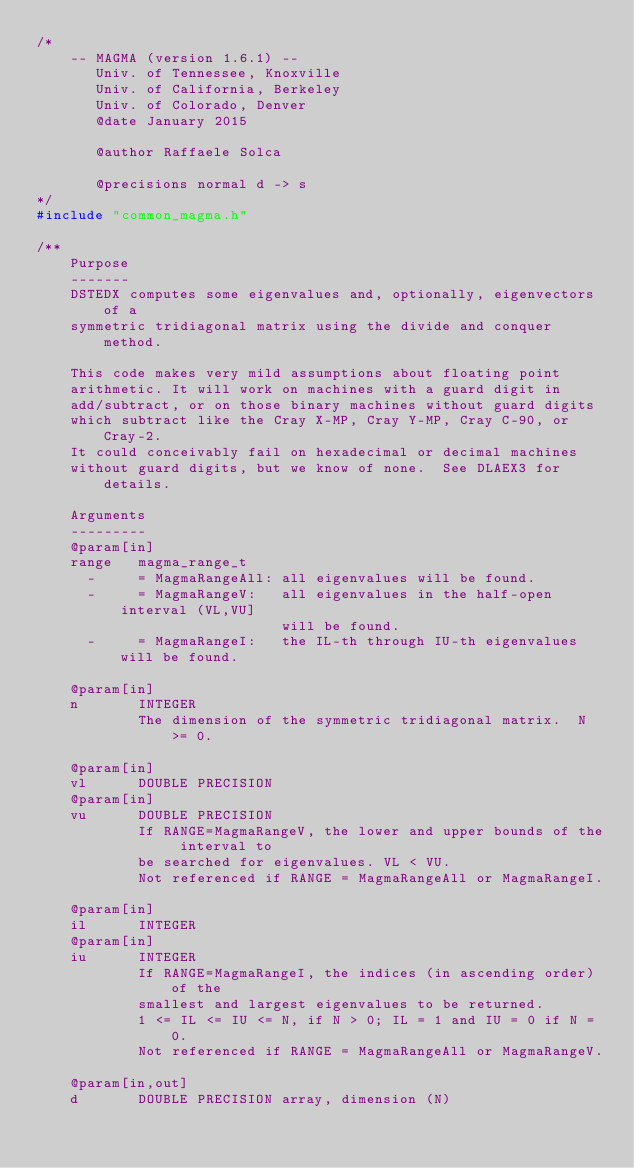<code> <loc_0><loc_0><loc_500><loc_500><_C++_>/*
    -- MAGMA (version 1.6.1) --
       Univ. of Tennessee, Knoxville
       Univ. of California, Berkeley
       Univ. of Colorado, Denver
       @date January 2015
       
       @author Raffaele Solca
       
       @precisions normal d -> s
*/
#include "common_magma.h"

/**
    Purpose
    -------
    DSTEDX computes some eigenvalues and, optionally, eigenvectors of a
    symmetric tridiagonal matrix using the divide and conquer method.

    This code makes very mild assumptions about floating point
    arithmetic. It will work on machines with a guard digit in
    add/subtract, or on those binary machines without guard digits
    which subtract like the Cray X-MP, Cray Y-MP, Cray C-90, or Cray-2.
    It could conceivably fail on hexadecimal or decimal machines
    without guard digits, but we know of none.  See DLAEX3 for details.

    Arguments
    ---------
    @param[in]
    range   magma_range_t
      -     = MagmaRangeAll: all eigenvalues will be found.
      -     = MagmaRangeV:   all eigenvalues in the half-open interval (VL,VU]
                             will be found.
      -     = MagmaRangeI:   the IL-th through IU-th eigenvalues will be found.

    @param[in]
    n       INTEGER
            The dimension of the symmetric tridiagonal matrix.  N >= 0.

    @param[in]
    vl      DOUBLE PRECISION
    @param[in]
    vu      DOUBLE PRECISION
            If RANGE=MagmaRangeV, the lower and upper bounds of the interval to
            be searched for eigenvalues. VL < VU.
            Not referenced if RANGE = MagmaRangeAll or MagmaRangeI.

    @param[in]
    il      INTEGER
    @param[in]
    iu      INTEGER
            If RANGE=MagmaRangeI, the indices (in ascending order) of the
            smallest and largest eigenvalues to be returned.
            1 <= IL <= IU <= N, if N > 0; IL = 1 and IU = 0 if N = 0.
            Not referenced if RANGE = MagmaRangeAll or MagmaRangeV.

    @param[in,out]
    d       DOUBLE PRECISION array, dimension (N)</code> 